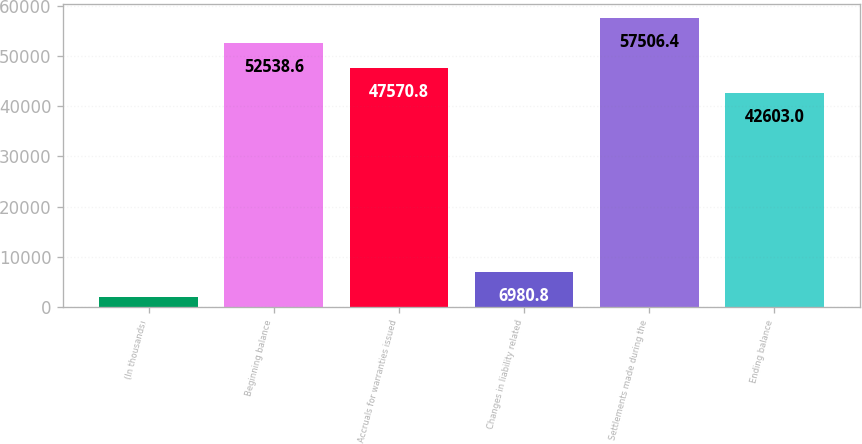Convert chart to OTSL. <chart><loc_0><loc_0><loc_500><loc_500><bar_chart><fcel>(In thousands)<fcel>Beginning balance<fcel>Accruals for warranties issued<fcel>Changes in liability related<fcel>Settlements made during the<fcel>Ending balance<nl><fcel>2013<fcel>52538.6<fcel>47570.8<fcel>6980.8<fcel>57506.4<fcel>42603<nl></chart> 